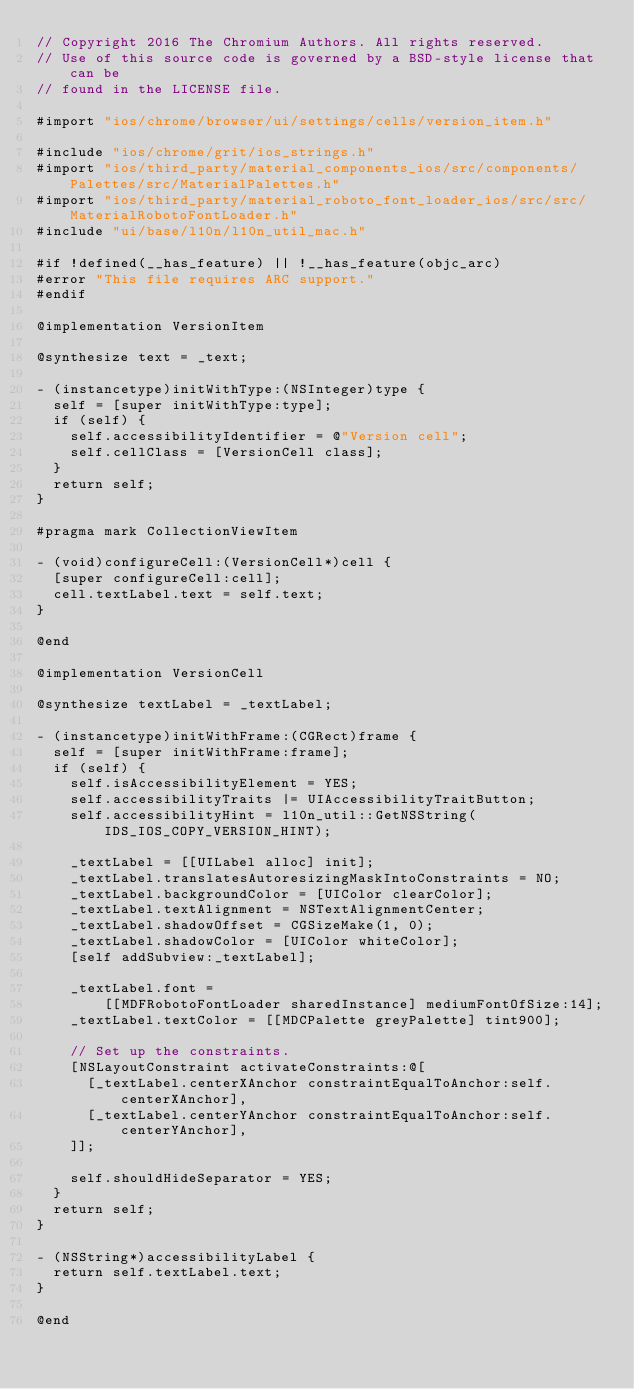Convert code to text. <code><loc_0><loc_0><loc_500><loc_500><_ObjectiveC_>// Copyright 2016 The Chromium Authors. All rights reserved.
// Use of this source code is governed by a BSD-style license that can be
// found in the LICENSE file.

#import "ios/chrome/browser/ui/settings/cells/version_item.h"

#include "ios/chrome/grit/ios_strings.h"
#import "ios/third_party/material_components_ios/src/components/Palettes/src/MaterialPalettes.h"
#import "ios/third_party/material_roboto_font_loader_ios/src/src/MaterialRobotoFontLoader.h"
#include "ui/base/l10n/l10n_util_mac.h"

#if !defined(__has_feature) || !__has_feature(objc_arc)
#error "This file requires ARC support."
#endif

@implementation VersionItem

@synthesize text = _text;

- (instancetype)initWithType:(NSInteger)type {
  self = [super initWithType:type];
  if (self) {
    self.accessibilityIdentifier = @"Version cell";
    self.cellClass = [VersionCell class];
  }
  return self;
}

#pragma mark CollectionViewItem

- (void)configureCell:(VersionCell*)cell {
  [super configureCell:cell];
  cell.textLabel.text = self.text;
}

@end

@implementation VersionCell

@synthesize textLabel = _textLabel;

- (instancetype)initWithFrame:(CGRect)frame {
  self = [super initWithFrame:frame];
  if (self) {
    self.isAccessibilityElement = YES;
    self.accessibilityTraits |= UIAccessibilityTraitButton;
    self.accessibilityHint = l10n_util::GetNSString(IDS_IOS_COPY_VERSION_HINT);

    _textLabel = [[UILabel alloc] init];
    _textLabel.translatesAutoresizingMaskIntoConstraints = NO;
    _textLabel.backgroundColor = [UIColor clearColor];
    _textLabel.textAlignment = NSTextAlignmentCenter;
    _textLabel.shadowOffset = CGSizeMake(1, 0);
    _textLabel.shadowColor = [UIColor whiteColor];
    [self addSubview:_textLabel];

    _textLabel.font =
        [[MDFRobotoFontLoader sharedInstance] mediumFontOfSize:14];
    _textLabel.textColor = [[MDCPalette greyPalette] tint900];

    // Set up the constraints.
    [NSLayoutConstraint activateConstraints:@[
      [_textLabel.centerXAnchor constraintEqualToAnchor:self.centerXAnchor],
      [_textLabel.centerYAnchor constraintEqualToAnchor:self.centerYAnchor],
    ]];

    self.shouldHideSeparator = YES;
  }
  return self;
}

- (NSString*)accessibilityLabel {
  return self.textLabel.text;
}

@end
</code> 